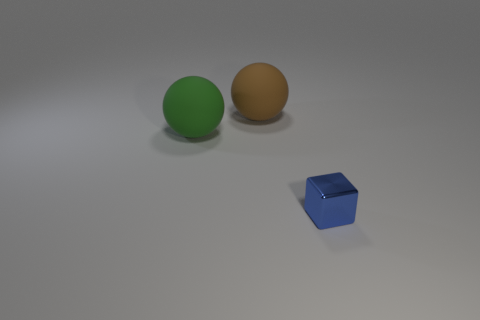Add 2 red shiny cylinders. How many objects exist? 5 Subtract all blocks. How many objects are left? 2 Add 2 small cyan rubber cylinders. How many small cyan rubber cylinders exist? 2 Subtract 0 red cubes. How many objects are left? 3 Subtract all large brown spheres. Subtract all cubes. How many objects are left? 1 Add 3 large brown matte spheres. How many large brown matte spheres are left? 4 